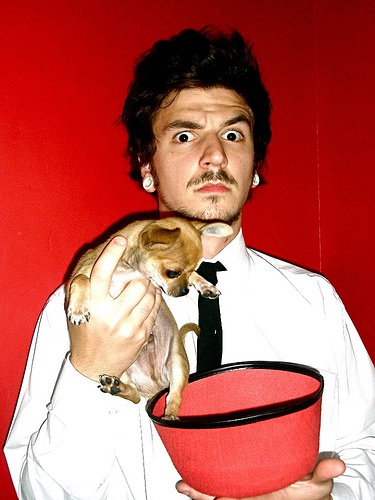Describe the objects in this image and their specific colors. I can see people in brown, white, black, and tan tones, bowl in brown, salmon, black, and red tones, dog in brown, ivory, tan, and olive tones, and tie in brown, black, ivory, and tan tones in this image. 